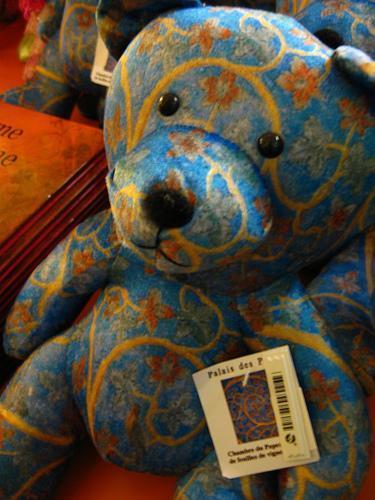How many bears are in the photo?
Give a very brief answer. 1. 